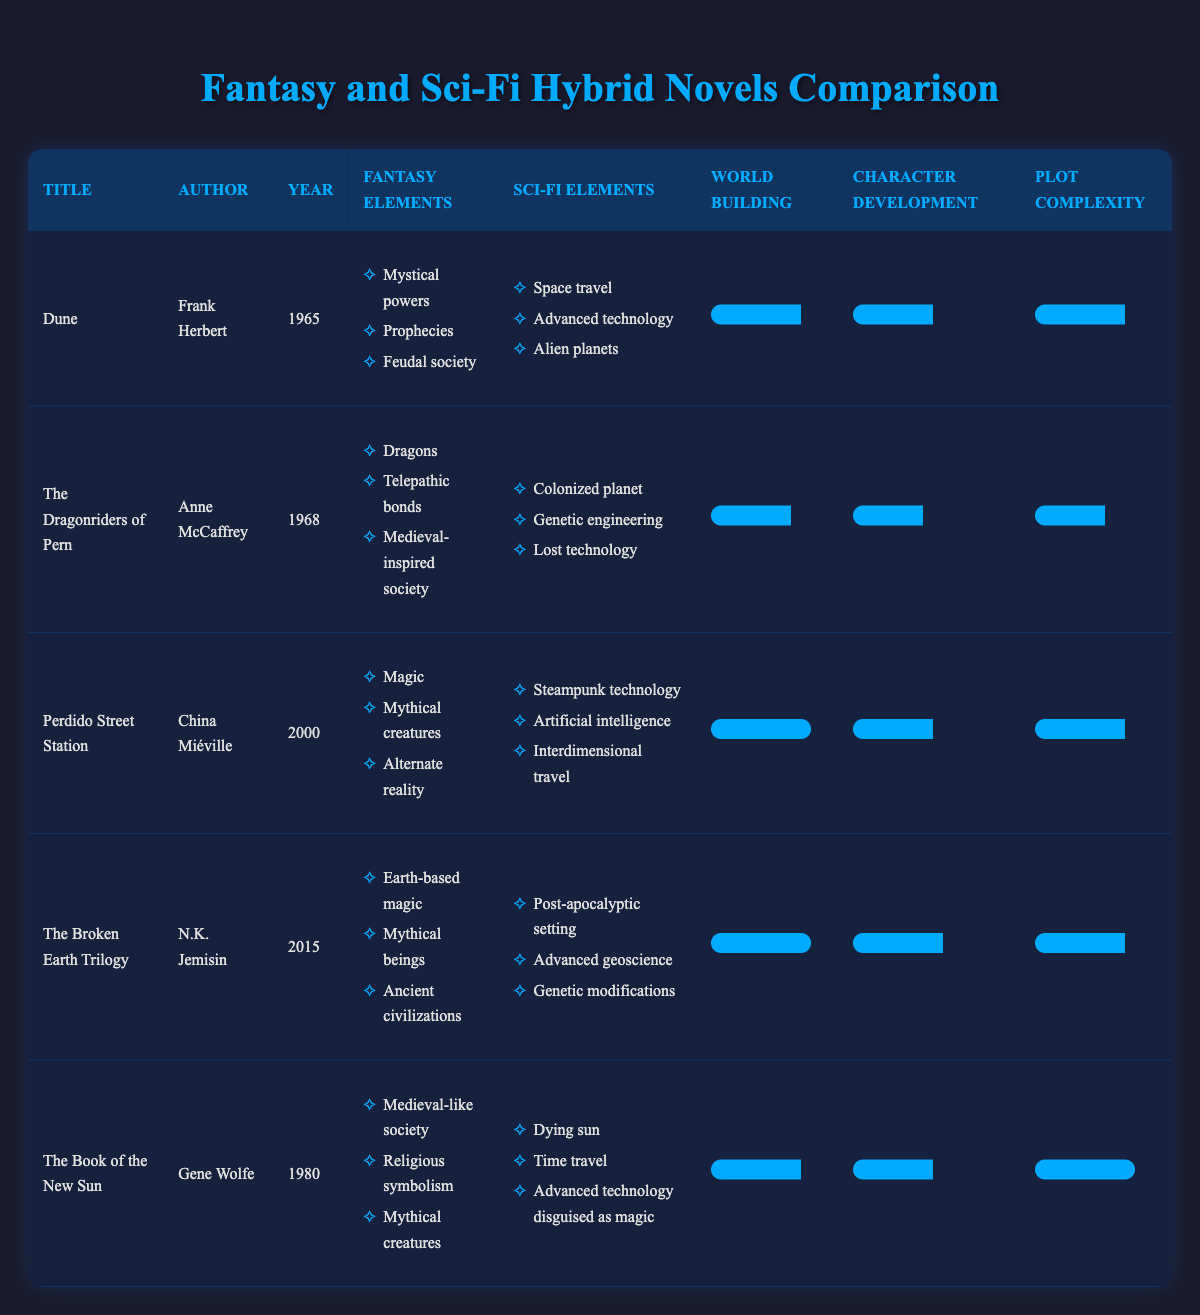What is the title of the earliest published novel in the table? The table lists the novels in chronological order based on their publication year. The earliest year is 1965, which corresponds to the novel "Dune" by Frank Herbert.
Answer: Dune Which novel features the most extensive world-building according to the ratings? By examining the ratings provided in the fourth column, "Perdido Street Station" and "The Broken Earth Trilogy" both have a world-building rating of 10, which is the highest in the table.
Answer: Perdido Street Station and The Broken Earth Trilogy Does "The Book of the New Sun" contain elements of both fantasy and science fiction? Reviewing the elements listed for "The Book of the New Sun," it includes fantasy elements such as "Medieval-like society" and sci-fi elements such as "Time travel." This confirms that it includes both genres.
Answer: Yes What is the average character development rating of the novels listed? To calculate the average character development rating, add the ratings of all novels: (8 + 7 + 8 + 9 + 8) = 40. Then divide by the number of novels (5): 40 / 5 = 8.
Answer: 8 Which author has the latest novel in the table? The last column shows the year of publication for each novel. "The Broken Earth Trilogy" by N.K. Jemisin was published in 2015, making it the latest novel listed.
Answer: N.K. Jemisin Is there any novel in the table that has a rating of 10 for plot complexity? Checking the table, "The Book of the New Sun" has a plot complexity rating of 10, which indicates a high level of complexity.
Answer: Yes What are the total number of fantasy elements present in "The Dragonriders of Pern"? There are three fantasy elements listed for "The Dragonriders of Pern": "Dragons," "Telepathic bonds," and "Medieval-inspired society." Therefore, the total is 3.
Answer: 3 Which two novels have the same character development rating? By reviewing the ratings in that specific column, "Dune" and "The Book of the New Sun" both have a character development rating of 8.
Answer: Dune and The Book of the New Sun What is the difference between the world-building ratings of "Dune" and "The Broken Earth Trilogy"? The world-building rating for "Dune" is 9, while for "The Broken Earth Trilogy," it is 10. The difference is calculated as: 10 - 9 = 1.
Answer: 1 